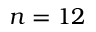Convert formula to latex. <formula><loc_0><loc_0><loc_500><loc_500>n = 1 2</formula> 